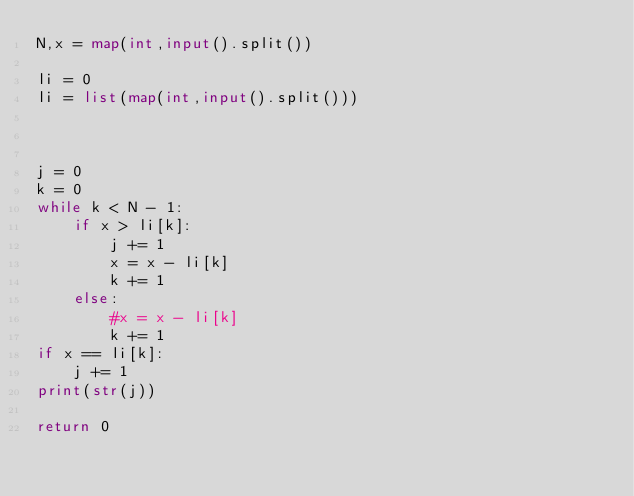<code> <loc_0><loc_0><loc_500><loc_500><_Python_>N,x = map(int,input().split())

li = 0
li = list(map(int,input().split()))



j = 0
k = 0
while k < N - 1:
    if x > li[k]:
        j += 1
        x = x - li[k]
        k += 1
    else:
        #x = x - li[k]
        k += 1
if x == li[k]:
    j += 1
print(str(j))

return 0</code> 